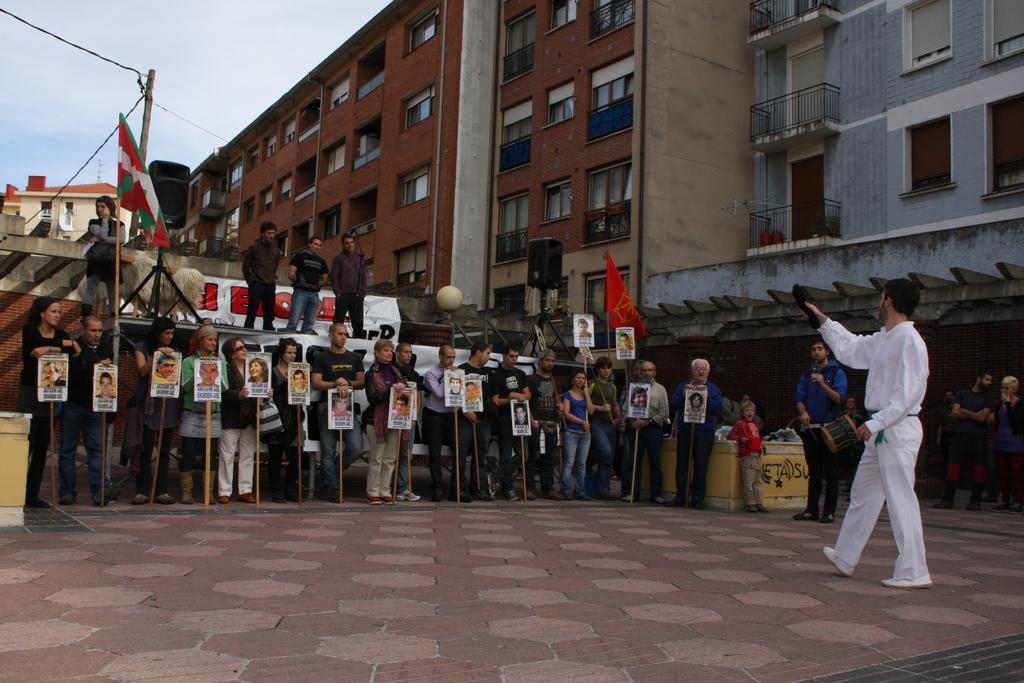Could you give a brief overview of what you see in this image? In this picture we can see a group of people standing on the ground where some are holding banners with their hands, flags, buildings with windows and in the background we can see sky. 